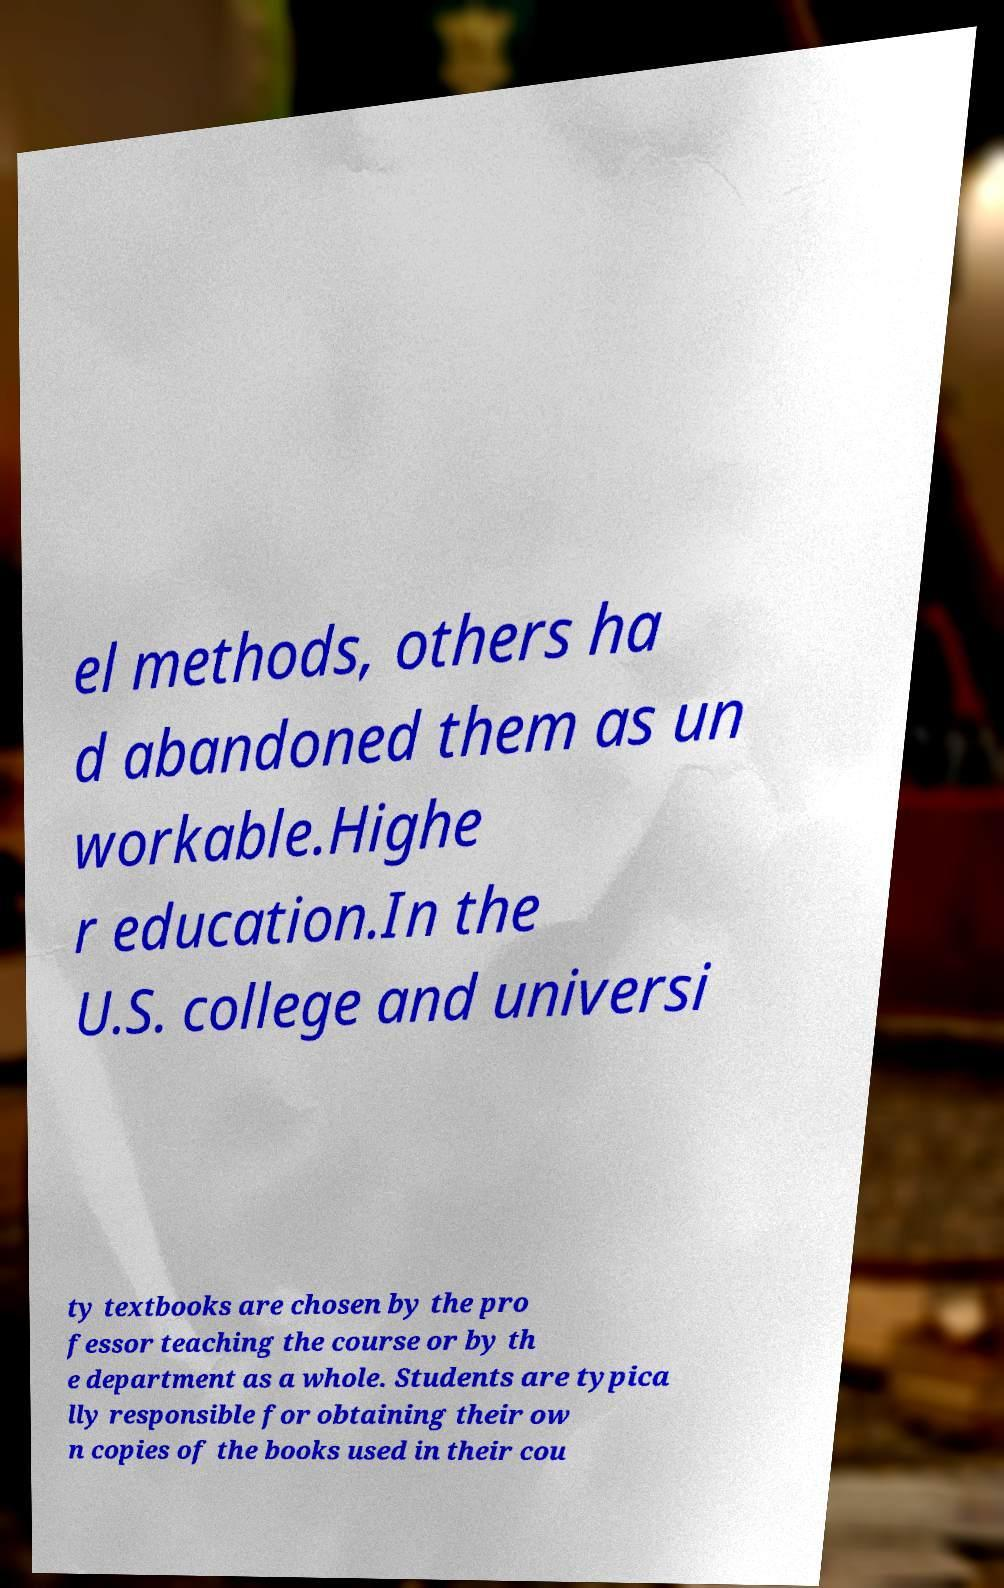Can you read and provide the text displayed in the image?This photo seems to have some interesting text. Can you extract and type it out for me? el methods, others ha d abandoned them as un workable.Highe r education.In the U.S. college and universi ty textbooks are chosen by the pro fessor teaching the course or by th e department as a whole. Students are typica lly responsible for obtaining their ow n copies of the books used in their cou 